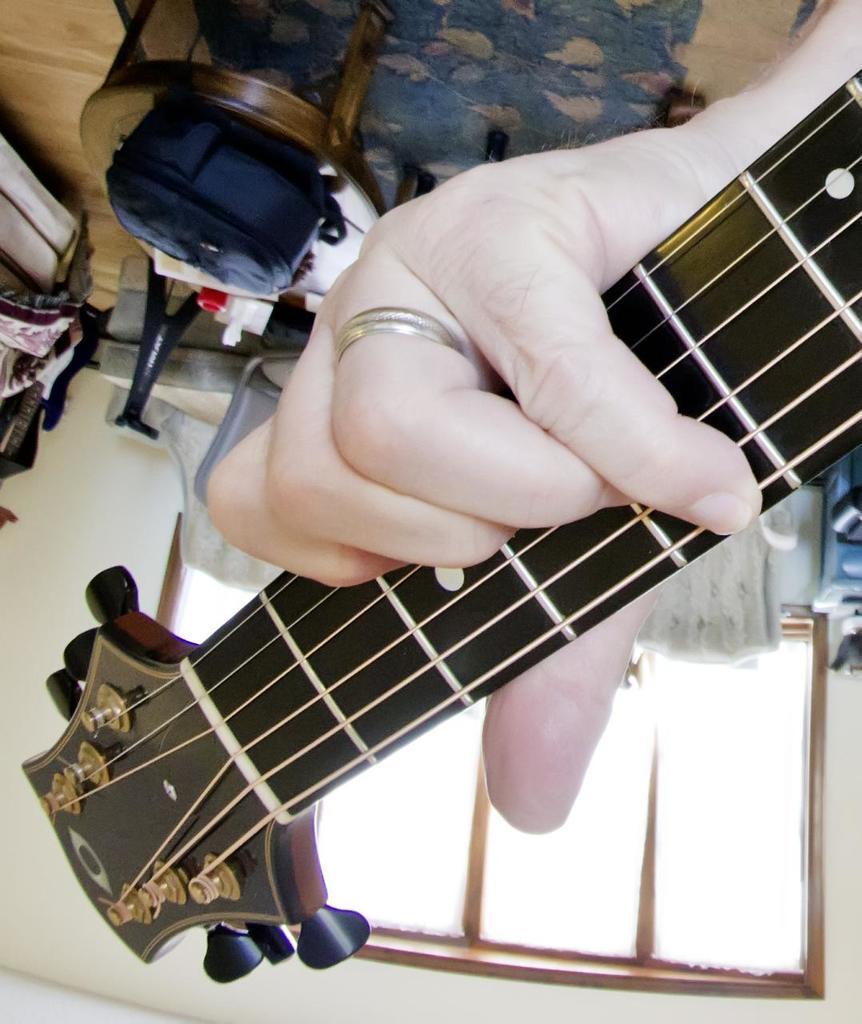Can you describe this image briefly? In this picture I can observe a guitar which is in black color. This guitar is in the human hand. I can observe ring to the finger. There is a table on which a blue color bag is placed on the floor. I can observe a carpet on the floor. 